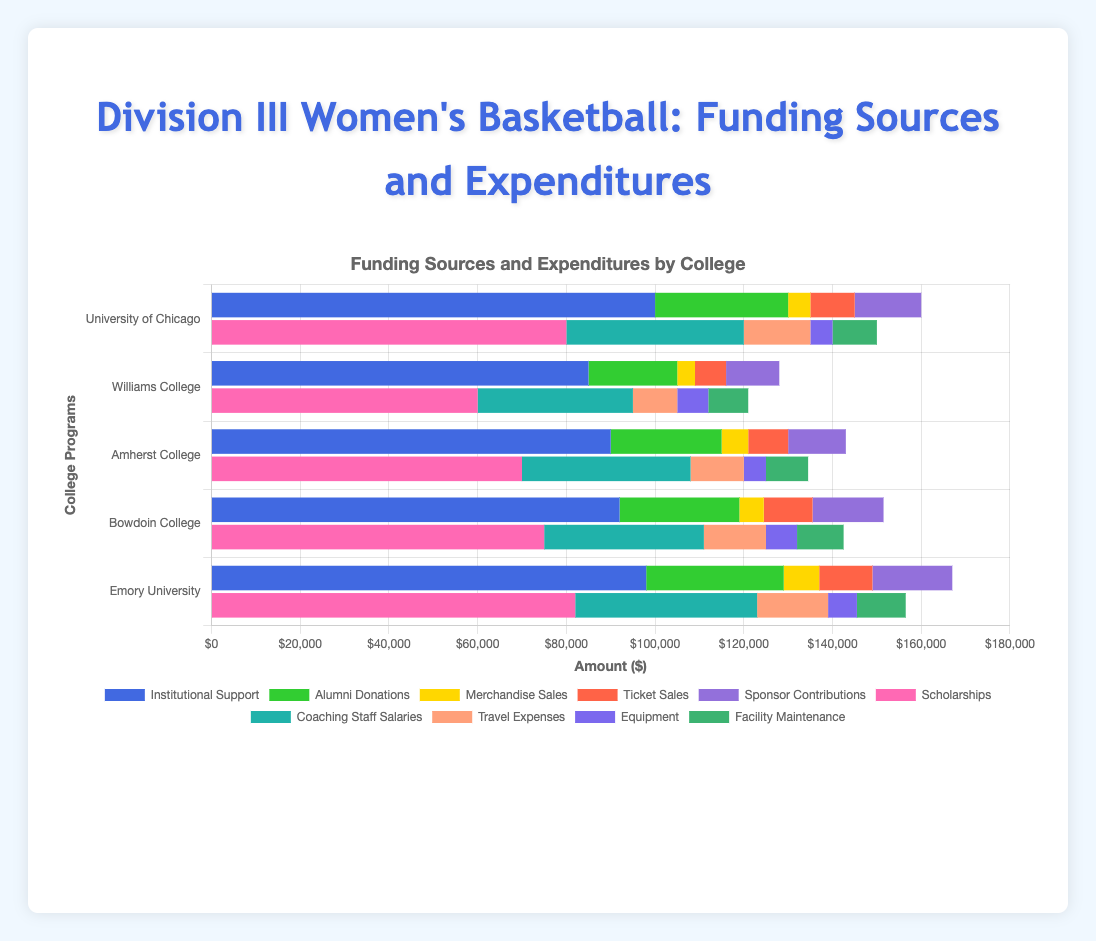Which College Program receives the highest amount of alumni donations? By observing the horizontal stacked bar chart, you can compare the segment representing alumni donations (green bar) among different programs. The highest segment of the alumni donations belongs to Emory University.
Answer: Emory University What is the total funding from merchandise sales across all programs? Add up the respective segments for merchandise sales (yellow bars) across all college programs: 5000 (University of Chicago) + 4000 (Williams College) + 6000 (Amherst College) + 5500 (Bowdoin College) + 8000 (Emory University) = 28500.
Answer: $28,500 Which program spends the most on coaching staff salaries? Compare the segment representing coaching staff salaries (teal bar) among different programs. The segment for University of Chicago is the longest, indicating it spends the most on coaching staff salaries.
Answer: University of Chicago What is the difference between the institutional support of University of Chicago and Williams College? Subtract the institutional support of Williams College (85,000) from that of University of Chicago (100,000): 100,000 - 85,000.
Answer: $15,000 How much more does Bowdoin College spend on travel expenses compared to Williams College? Compare the segment lengths for travel expenses (orange bars): 14000 (Bowdoin College) - 10000 (Williams College).
Answer: $4,000 Which college program has the smallest expenditure on equipment? Find the shortest segment representing expenditures on equipment (purple bars) across the programs. The shortest bar is for University of Chicago and Amherst College, both spending 5000 on equipment.
Answer: University of Chicago and Amherst College Among the programs, which has the greatest total funding? Sum up all the funding sources for each program; the one with the highest sum is the answer. Summing up for Emory University, it's the highest: 98000 + 31000 + 8000 + 12000 + 18000 = 167000.
Answer: Emory University Which college's combined expenditures on scholarships and travel expenses are the greatest? Sum the scholarships and travel expenses segments for each program and compare. For Emory University, it's the highest: 82000 + 16000 = 98000.
Answer: Emory University 